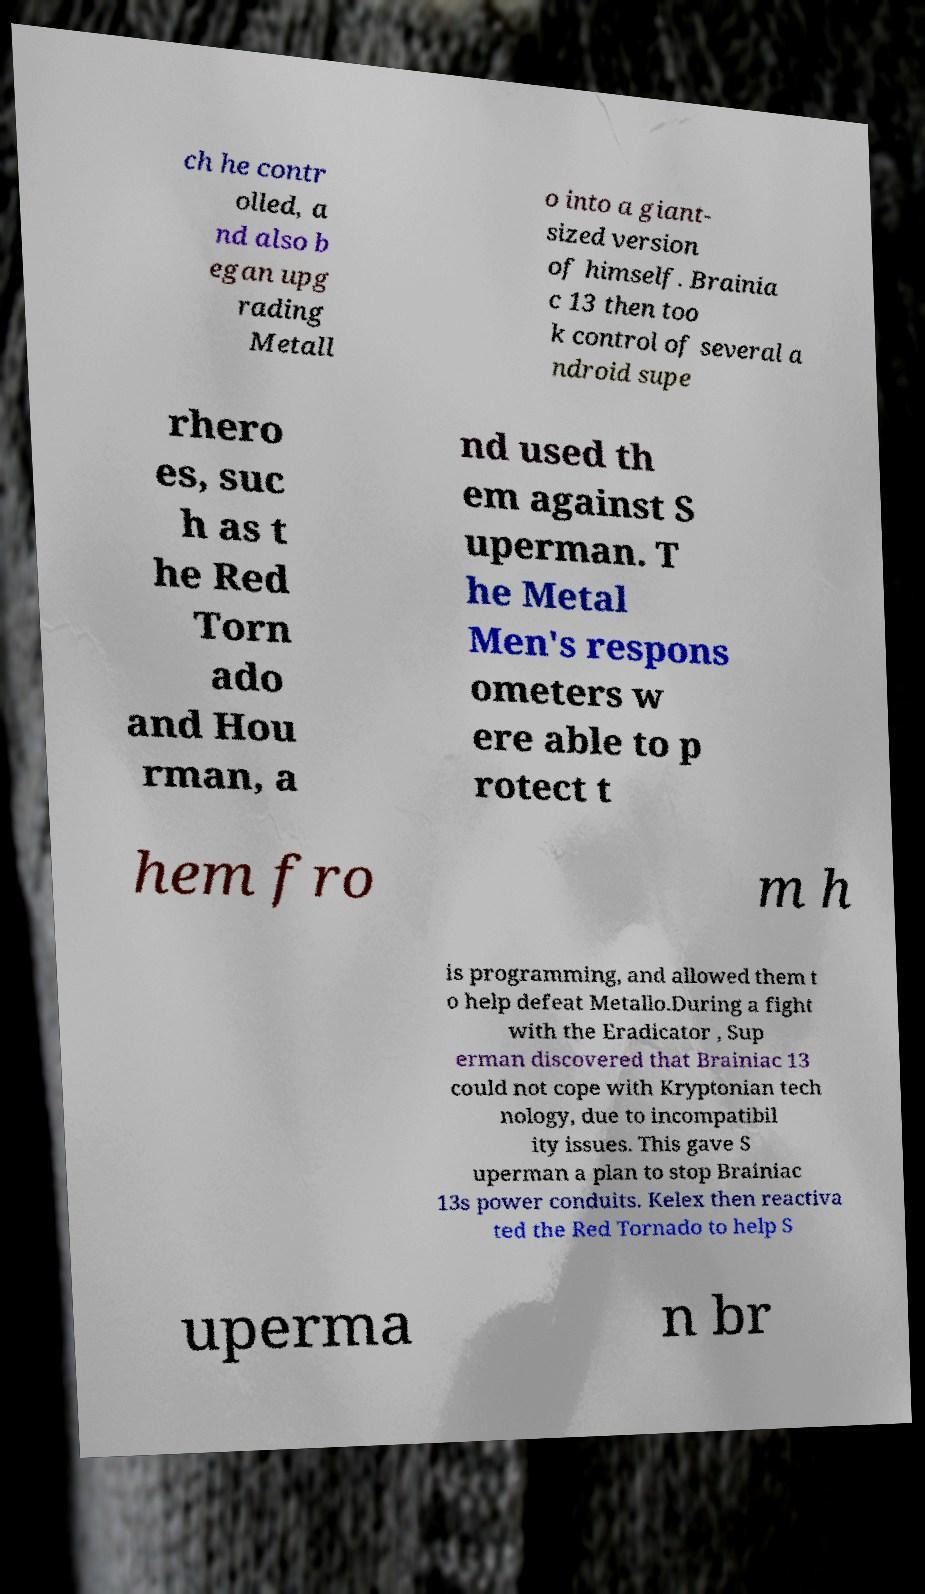For documentation purposes, I need the text within this image transcribed. Could you provide that? ch he contr olled, a nd also b egan upg rading Metall o into a giant- sized version of himself. Brainia c 13 then too k control of several a ndroid supe rhero es, suc h as t he Red Torn ado and Hou rman, a nd used th em against S uperman. T he Metal Men's respons ometers w ere able to p rotect t hem fro m h is programming, and allowed them t o help defeat Metallo.During a fight with the Eradicator , Sup erman discovered that Brainiac 13 could not cope with Kryptonian tech nology, due to incompatibil ity issues. This gave S uperman a plan to stop Brainiac 13s power conduits. Kelex then reactiva ted the Red Tornado to help S uperma n br 